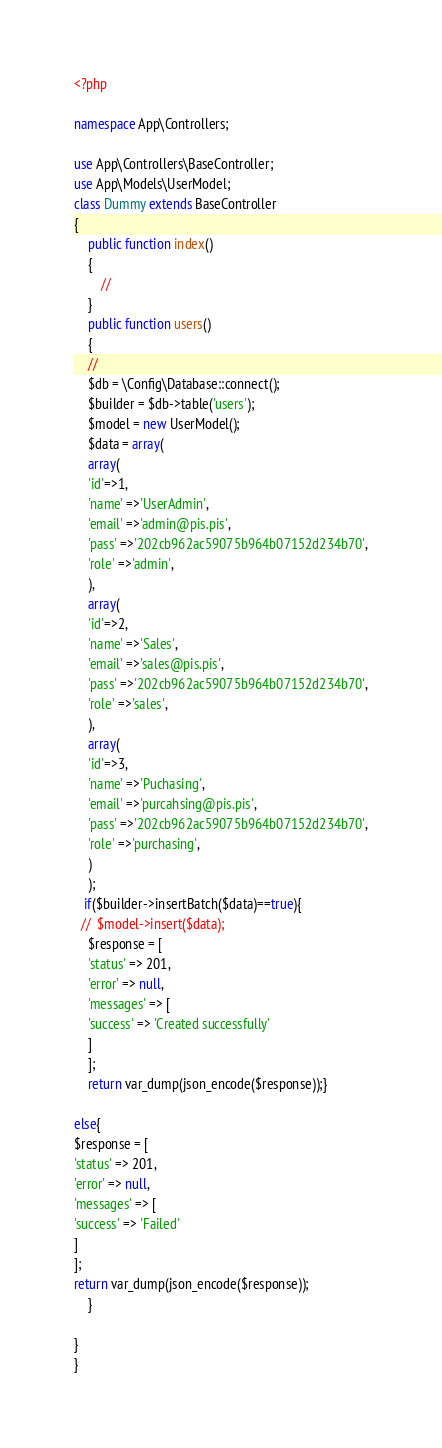<code> <loc_0><loc_0><loc_500><loc_500><_PHP_><?php

namespace App\Controllers;

use App\Controllers\BaseController;
use App\Models\UserModel;
class Dummy extends BaseController
{
    public function index()
    {
        //
    }
    public function users()
    {
    //
    $db = \Config\Database::connect();
    $builder = $db->table('users');
    $model = new UserModel();
    $data = array(
    array(
    'id'=>1,    
    'name' =>'UserAdmin',
    'email' =>'admin@pis.pis',
    'pass' =>'202cb962ac59075b964b07152d234b70',
    'role' =>'admin',
    ),
    array(
    'id'=>2,
    'name' =>'Sales',
    'email' =>'sales@pis.pis',
    'pass' =>'202cb962ac59075b964b07152d234b70',
    'role' =>'sales',
    ),
    array(
    'id'=>3,
    'name' =>'Puchasing',
    'email' =>'purcahsing@pis.pis',
    'pass' =>'202cb962ac59075b964b07152d234b70',
    'role' =>'purchasing',
    )
    );
   if($builder->insertBatch($data)==true){ 
  //  $model->insert($data);
    $response = [
    'status' => 201,
    'error' => null,
    'messages' => [
    'success' => 'Created successfully' 
    ]
    ];
    return var_dump(json_encode($response));}
    
else{
$response = [
'status' => 201,
'error' => null,
'messages' => [
'success' => 'Failed'
]
];
return var_dump(json_encode($response));
    }
    
}
}</code> 